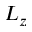<formula> <loc_0><loc_0><loc_500><loc_500>L _ { z }</formula> 